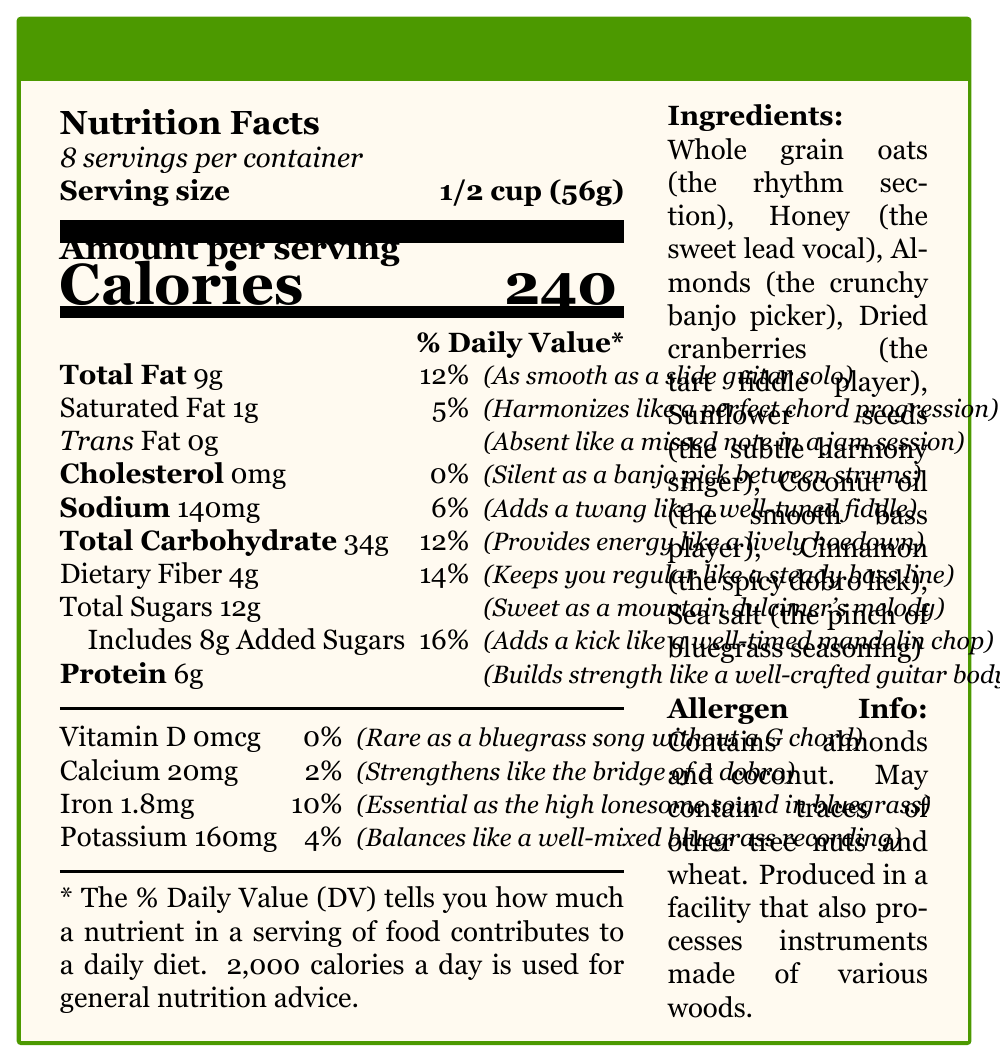what is the serving size of Pickin' and Grinnin' Granola? The serving size is stated as "1/2 cup (56g)" in the document.
Answer: 1/2 cup (56g) how many calories are in one serving? The document shows that each serving has 240 calories.
Answer: 240 how many servings are there per container? The document indicates there are "about 8" servings per container.
Answer: About 8 what amount of sodium does one serving contain? The document specifies that there are 140mg of sodium per serving.
Answer: 140mg what is the total fat content per serving, and how is it described musically? The total fat content is 9g, described as "As smooth as a slide guitar solo."
Answer: 9g, As smooth as a slide guitar solo which ingredient acts as the "sweet lead vocal"? A. Almonds B. Honey C. Sunflower seeds D. Dried cranberries The document lists honey as "the sweet lead vocal."
Answer: B. Honey how much protein is in one serving? The document states that each serving contains 6g of protein.
Answer: 6g which vitamin is rare as a bluegrass song without a G chord? The document describes Vitamin D as "Rare as a bluegrass song without a G chord."
Answer: Vitamin D does the granola contain any trans fat? The document shows that there are 0g of trans fat.
Answer: No what is the main idea of the document? The document outlines the nutritional content per serving, lists the ingredients, and highlights allergens, with playful musical analogies for each item.
Answer: The document provides detailed nutrition information for Pickin' and Grinnin' Granola, using witty musical descriptions to characterize each nutritional element and ingredient. which of the following elements adds a twang like a well-tuned fiddle? I. Sodium II. Total Sugars III. Protein IV. Calcium The document describes sodium as adding "a twang like a well-tuned fiddle."
Answer: I. Sodium what is the daily value percentage of dietary fiber in one serving? The document includes that the dietary fiber provides 14% of the daily value.
Answer: 14% is the amount of calcium in the granola greater than the amount of potassium? The document shows that calcium is 20mg per serving, while potassium is 160mg per serving.
Answer: No what are the allergen warnings mentioned? The document specifies these allergens under "Allergen Info."
Answer: Contains almonds and coconut. May contain traces of other tree nuts and wheat. what is the musical property description for total sugars? The document describes total sugars as "Sweet as a mountain dulcimer's melody."
Answer: Sweet as a mountain dulcimer's melody which ingredient is identified as 'the tart fiddle player'? The document lists dried cranberries as "the tart fiddle player."
Answer: Dried cranberries how much added sugar is included in each serving, and what is its daily value percentage? Each serving includes 8g of added sugars, accounting for 16% of the daily value.
Answer: 8g, 16% what is the musical analogy for the amount of saturated fat? The document describes the saturated fat content as "Harmonizes like a perfect chord progression."
Answer: Harmonizes like a perfect chord progression how many grams of total carbohydrate are in a serving, and what energy-related description is given? Each serving contains 34g of total carbohydrate, described as "Provides energy like a lively hoedown."
Answer: 34g, Provides energy like a lively hoedown what is the daily value percentage of iron in one serving? The document lists the daily value percentage of iron as 10%.
Answer: 10% which ingredient is identified as 'the crunchy banjo picker'? The document lists almonds as "the crunchy banjo picker."
Answer: Almonds what is the allergen information specifically regarding the facility where the granola is produced? The document indicates potential traces of other tree nuts and wheat, processed in a facility that could also process wooden instruments.
Answer: May contain traces of other tree nuts and wheat. Produced in a facility that also processes instruments made of various woods. what is the reason for including sea salt in the granola, according to the bluegrass theme descriptions? The document indicates that sea salt adds "the pinch of bluegrass seasoning."
Answer: Adds a pinch of bluegrass seasoning how is the amount of total carbohydrate described in a lively, music-themed manner? The document employs the analogy "Provides energy like a lively hoedown" for the total carbohydrate content.
Answer: Provides energy like a lively hoedown what does the document say about the presence of Vitamin D in the granola? The document states that there is 0mcg of Vitamin D, making up 0% of the daily value.
Answer: 0mcg, 0% what is described as "Strengthens like the bridge of a dobro" in the document? The document describes calcium's role as "Strengthens like the bridge of a dobro."
Answer: Calcium what type of information is missing if I want to know the specifics of ingredient sourcing? The document does not include details about the sourcing of ingredients.
Answer: Cannot be determined 